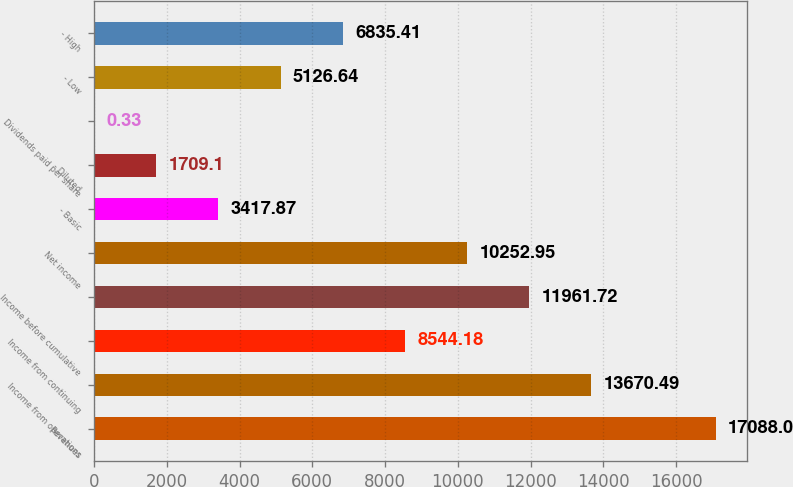Convert chart. <chart><loc_0><loc_0><loc_500><loc_500><bar_chart><fcel>Revenues<fcel>Income from operations<fcel>Income from continuing<fcel>Income before cumulative<fcel>Net income<fcel>- Basic<fcel>- Diluted<fcel>Dividends paid per share<fcel>- Low<fcel>- High<nl><fcel>17088<fcel>13670.5<fcel>8544.18<fcel>11961.7<fcel>10253<fcel>3417.87<fcel>1709.1<fcel>0.33<fcel>5126.64<fcel>6835.41<nl></chart> 